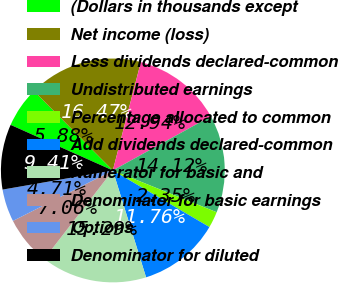Convert chart. <chart><loc_0><loc_0><loc_500><loc_500><pie_chart><fcel>(Dollars in thousands except<fcel>Net income (loss)<fcel>Less dividends declared-common<fcel>Undistributed earnings<fcel>Percentage allocated to common<fcel>Add dividends declared-common<fcel>Numerator for basic and<fcel>Denominator for basic earnings<fcel>Options<fcel>Denominator for diluted<nl><fcel>5.88%<fcel>16.47%<fcel>12.94%<fcel>14.12%<fcel>2.35%<fcel>11.76%<fcel>15.29%<fcel>7.06%<fcel>4.71%<fcel>9.41%<nl></chart> 